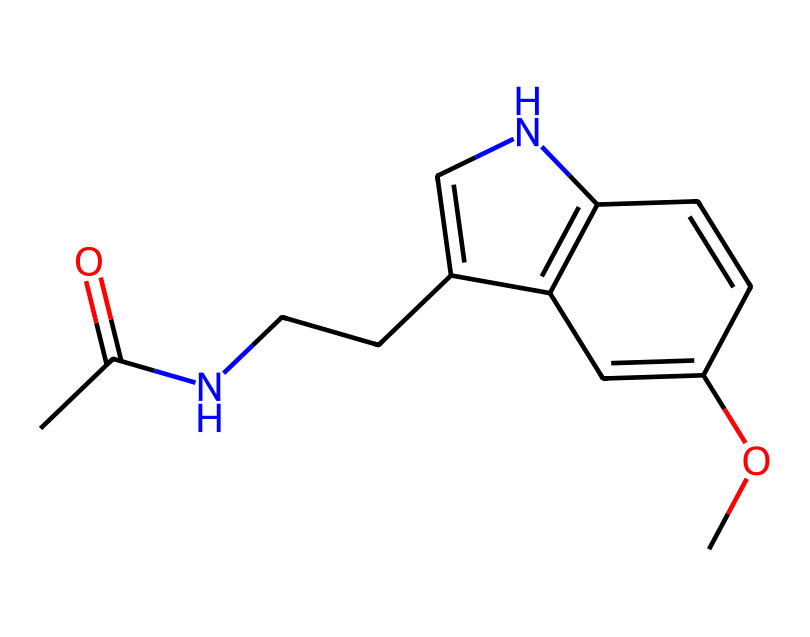What is the chemical name of this compound? The SMILES representation corresponds to melatonin, a hormone that regulates sleep-wake cycles. By analyzing the structure, it can be identified that the chemical name reflects the molecular configuration seen in the SMILES.
Answer: melatonin How many carbon atoms are present in this chemical structure? By examining the SMILES notation, we can count the carbon (C) characters. The total number of carbon atoms leads to the answer. In this case, there are 13 carbons present.
Answer: 13 What functional groups are present in this molecule? By looking at the SMILES and recognizing distinct groups, we identify that the molecule contains an amide (the -N and =O group) and an ether (the -O- connected to two carbons), which classify its functional groups.
Answer: amide and ether How many double bonds are in this chemical structure? In the SMILES representation, double bonds are indicated by '=' signs. By counting each occurrence of '=' in the structure, we find that there are three double bonds present in melatonin.
Answer: 3 What is the molecular formula of melatonin? The chemical structure can be interpreted from the SMILES to derive the molecular formula. By counting the atoms of each element (C, H, N, O) based on the structure, we arrive at the molecular formula C13H16N2O2.
Answer: C13H16N2O2 Does this chemical structure contain nitrogen atoms? The SMILES includes the letter 'N', which indicates nitrogen atoms are present in this structure. Upon inspection, there are two nitrogen atoms in the chemical structure.
Answer: yes, 2 